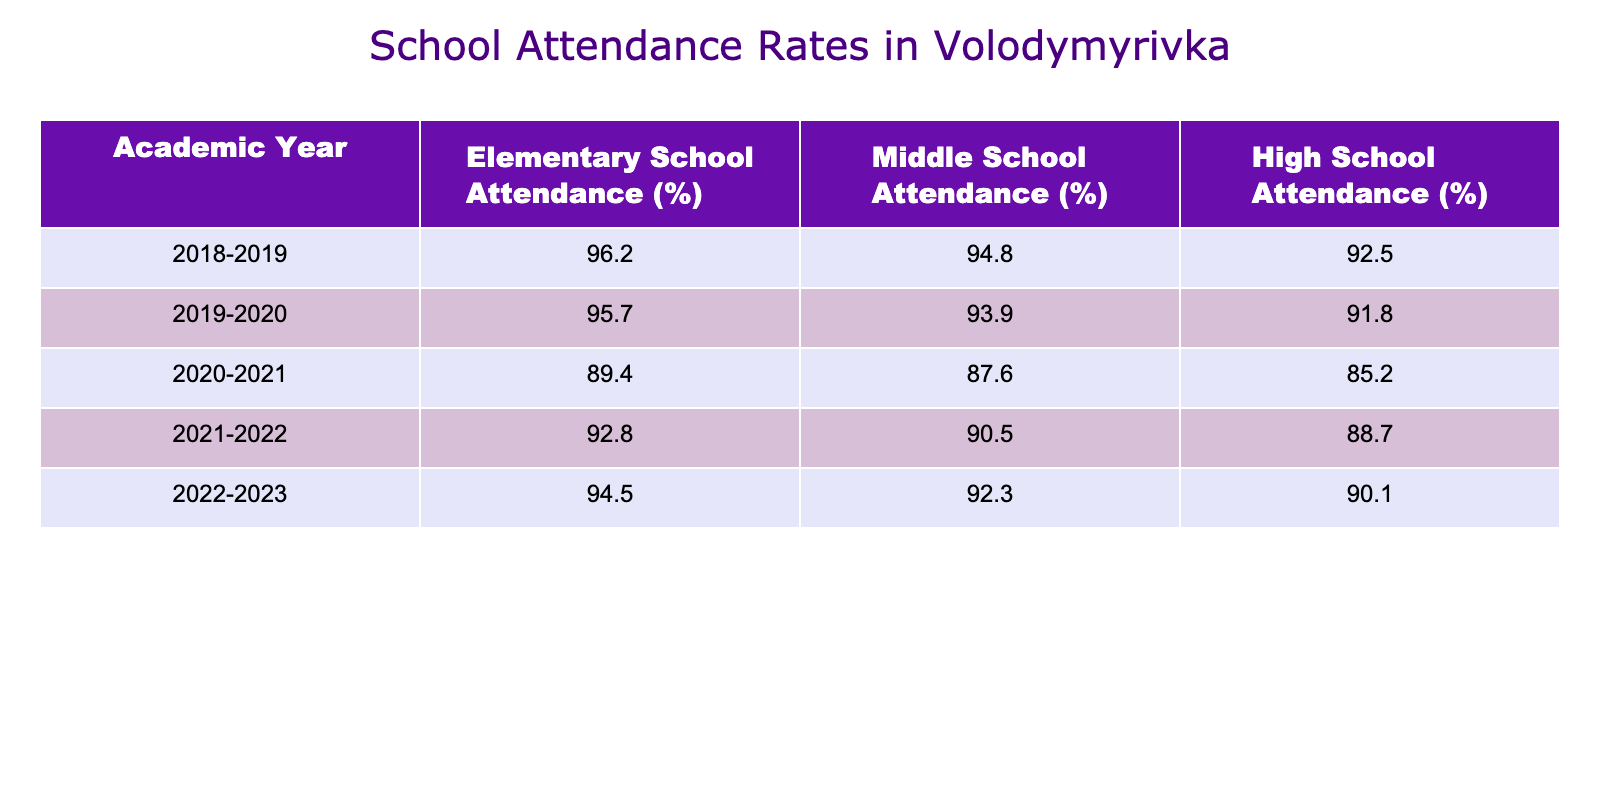What was the attendance rate for elementary school in 2020-2021? In the year 2020-2021, the table shows the attendance rate for elementary school as 89.4%.
Answer: 89.4% Which academic year had the highest middle school attendance rate? By comparing the middle school attendance rates from all five years, the highest rate is 94.8%, which occurred in the academic year 2018-2019.
Answer: 2018-2019 What is the difference in high school attendance between 2018-2019 and 2022-2023? High school attendance in 2018-2019 was 92.5%, and in 2022-2023 it was 90.1%. The difference is calculated as 92.5% - 90.1% = 2.4%.
Answer: 2.4% What was the average elementary school attendance over the five years? The attendance rates are 96.2%, 95.7%, 89.4%, 92.8%, and 94.5%. Summing these gives 468.6%, and dividing by 5 yields an average of 93.72%.
Answer: 93.72% Did high school attendance improve between 2021-2022 and 2022-2023? In 2021-2022, high school attendance was 88.7%, and in 2022-2023, it improved to 90.1%. Since 90.1% is greater than 88.7%, attendance did improve.
Answer: Yes What trend do you see in middle school attendance from 2018-2019 to 2020-2021? Middle school attendance decreased over these years: it was 94.8% in 2018-2019 and dropped to 87.6% in 2020-2021, indicating a declining trend.
Answer: Declining What year had the lowest overall attendance across all school levels? By analyzing the years, 2020-2021 had the lowest attendance rates overall: 89.4% for elementary, 87.6% for middle, and 85.2% for high school.
Answer: 2020-2021 What was the percentage increase in elementary school attendance from 2020-2021 to 2021-2022? Elementary school attendance increased from 89.4% in 2020-2021 to 92.8% in 2021-2022. The percentage increase is calculated as (92.8% - 89.4%) / 89.4% * 100 = 3.79%.
Answer: 3.79% Which school level had the most consistent attendance rates over the five years? By examining the attendance rates, high school attendance fluctuates more widely compared to elementary and middle school. The elementary school rates show generally higher numbers with smaller variation, indicating more consistency.
Answer: Elementary school 